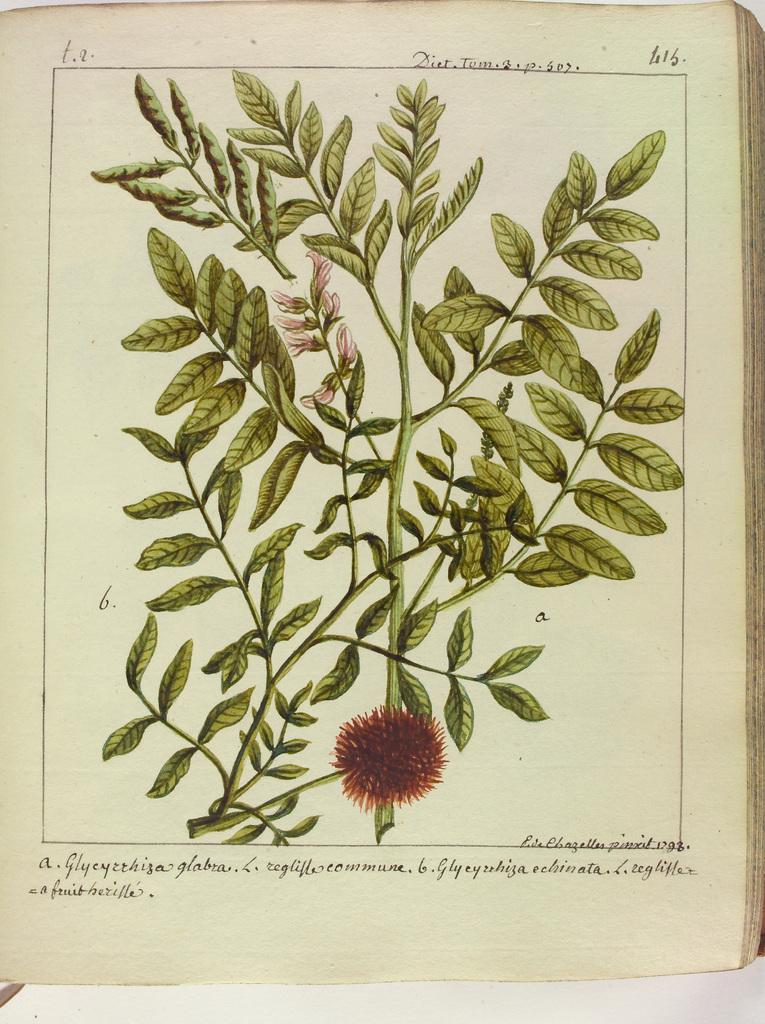What is one object visible in the image? There is a book in the image. What type of living organism can be seen in the image? There is a plant in the image. What decorative elements are present in the image? There are flowers in the image. What is written on the paper in the image? There is text and numbers on the paper in the image. What color is the background of the image? The background of the image is white in color. What type of crayon is being used to draw on the machine in the image? There is no crayon or machine present in the image. 